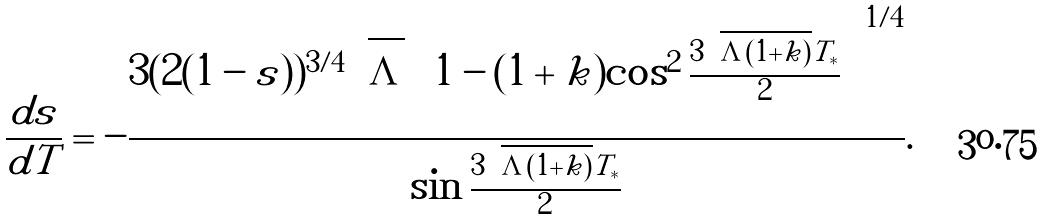<formula> <loc_0><loc_0><loc_500><loc_500>\frac { d { s } } { d T } = - \frac { 3 ( 2 ( 1 - { s } ) ) ^ { 3 / 4 } \sqrt { \Lambda } \left ( 1 - ( 1 + k ) \cos ^ { 2 } \frac { 3 \sqrt { \Lambda ( 1 + k ) } T _ { * } } { 2 } \right ) ^ { 1 / 4 } } { \sin \frac { 3 \sqrt { \Lambda ( 1 + k ) } T _ { * } } { 2 } } .</formula> 